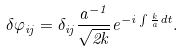<formula> <loc_0><loc_0><loc_500><loc_500>\delta \varphi _ { i j } = \delta _ { i j } \frac { a ^ { - 1 } } { \sqrt { 2 k } } e ^ { - i \int \frac { k } { a } d t } .</formula> 